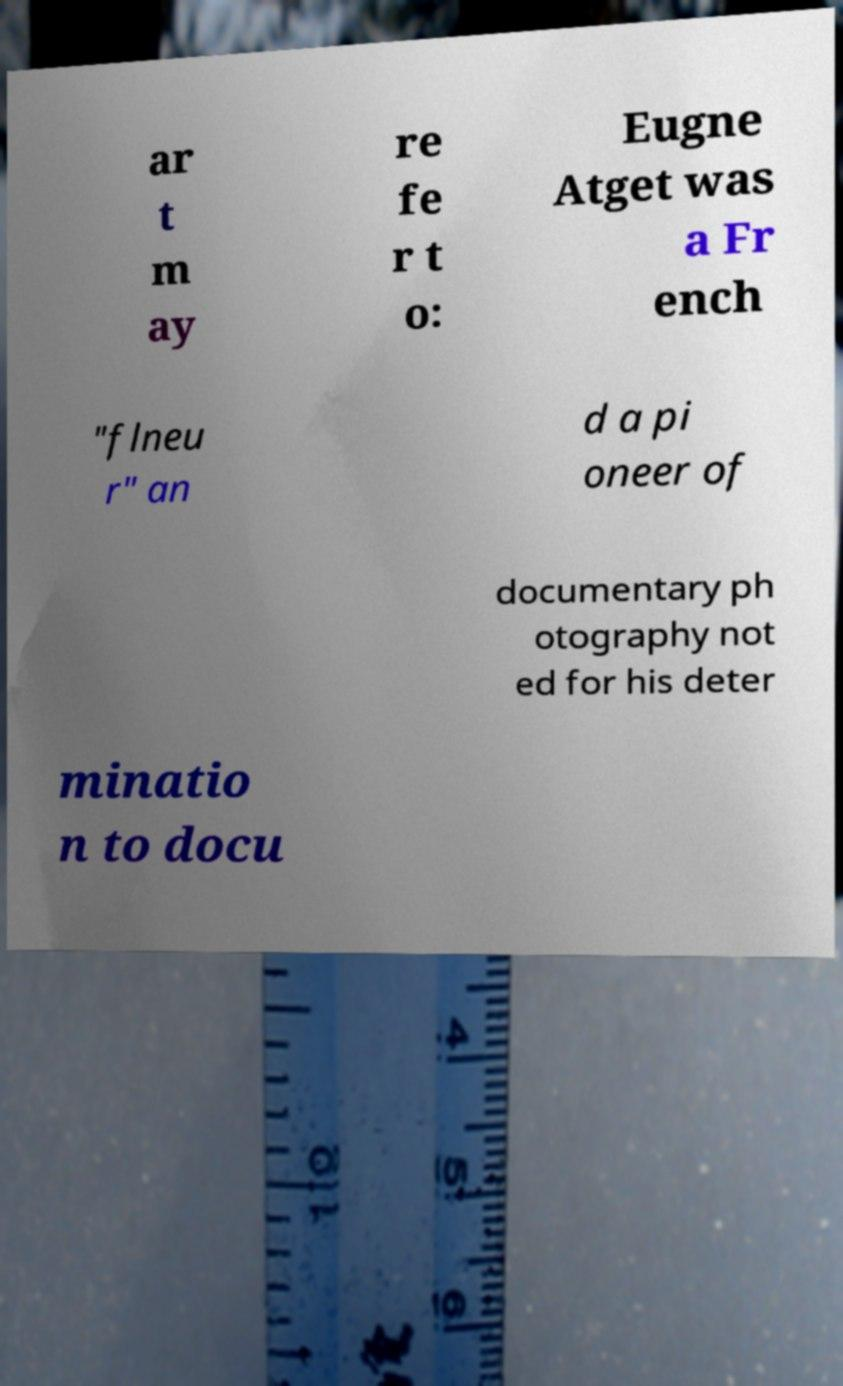For documentation purposes, I need the text within this image transcribed. Could you provide that? ar t m ay re fe r t o: Eugne Atget was a Fr ench "flneu r" an d a pi oneer of documentary ph otography not ed for his deter minatio n to docu 